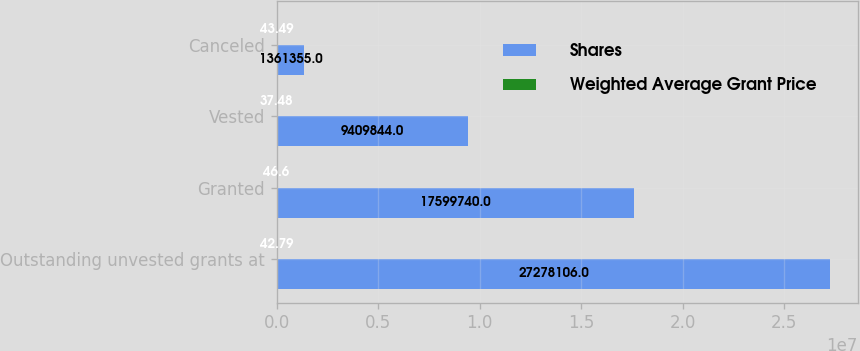Convert chart. <chart><loc_0><loc_0><loc_500><loc_500><stacked_bar_chart><ecel><fcel>Outstanding unvested grants at<fcel>Granted<fcel>Vested<fcel>Canceled<nl><fcel>Shares<fcel>2.72781e+07<fcel>1.75997e+07<fcel>9.40984e+06<fcel>1.36136e+06<nl><fcel>Weighted Average Grant Price<fcel>42.79<fcel>46.6<fcel>37.48<fcel>43.49<nl></chart> 